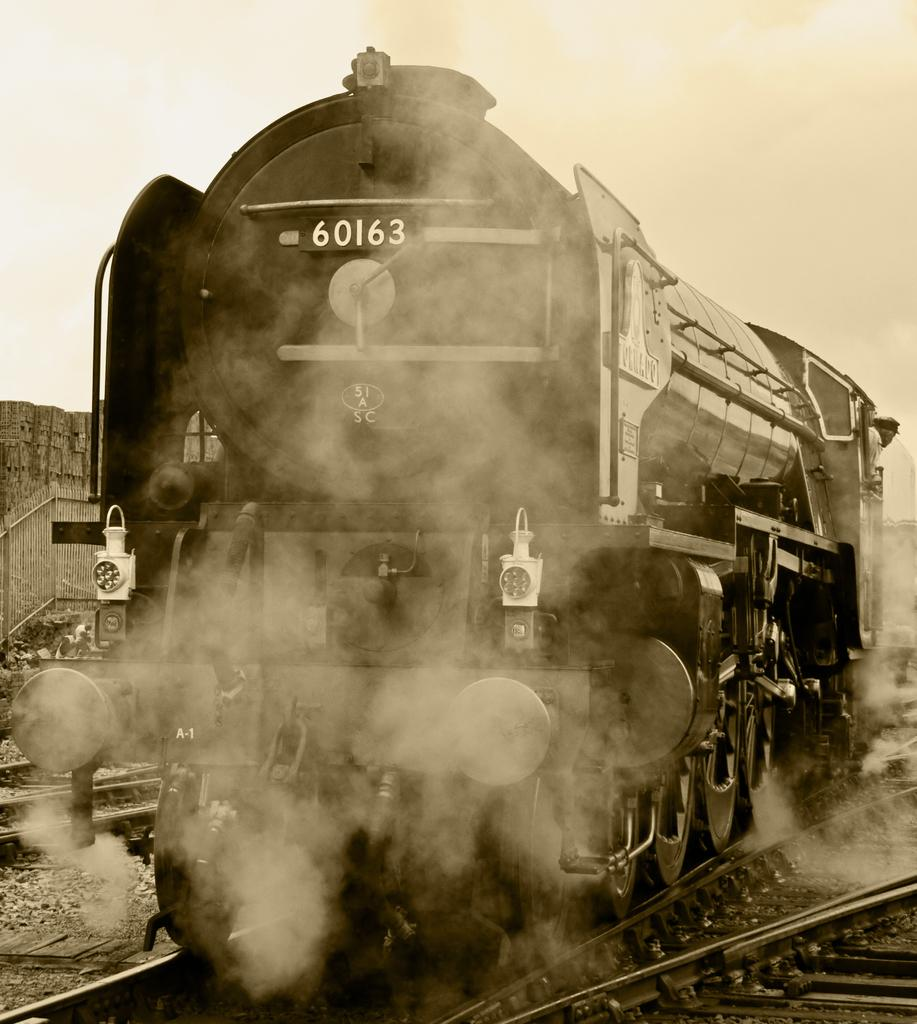What is the color scheme of the image? The image is black and white. What is the main subject of the image? There is a train in the image. What is the train traveling on? There are railway tracks in the image. What can be seen below the train? The ground is visible in the image. Are there any objects on the ground? Yes, there are objects on the ground. What is visible above the train? The sky is visible in the image. Are there any objects on the left side of the image? Yes, there are objects on the left side of the image. What type of lunchroom can be seen in the image? There is no lunchroom present in the image. What is the income of the train conductor in the image? There is no information about the train conductor's income in the image. 